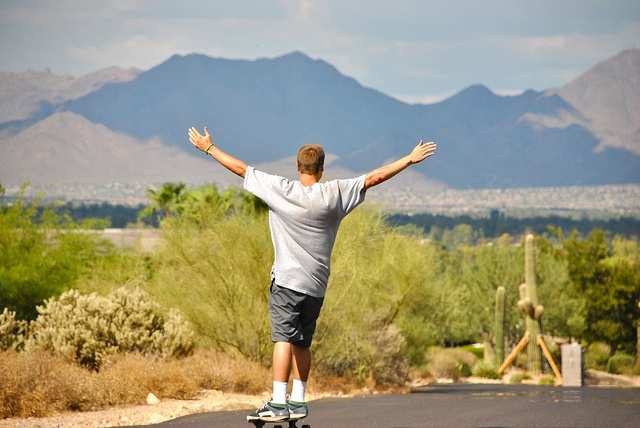Describe the objects in this image and their specific colors. I can see people in gray, white, darkgray, and black tones and skateboard in gray, black, maroon, and darkgreen tones in this image. 